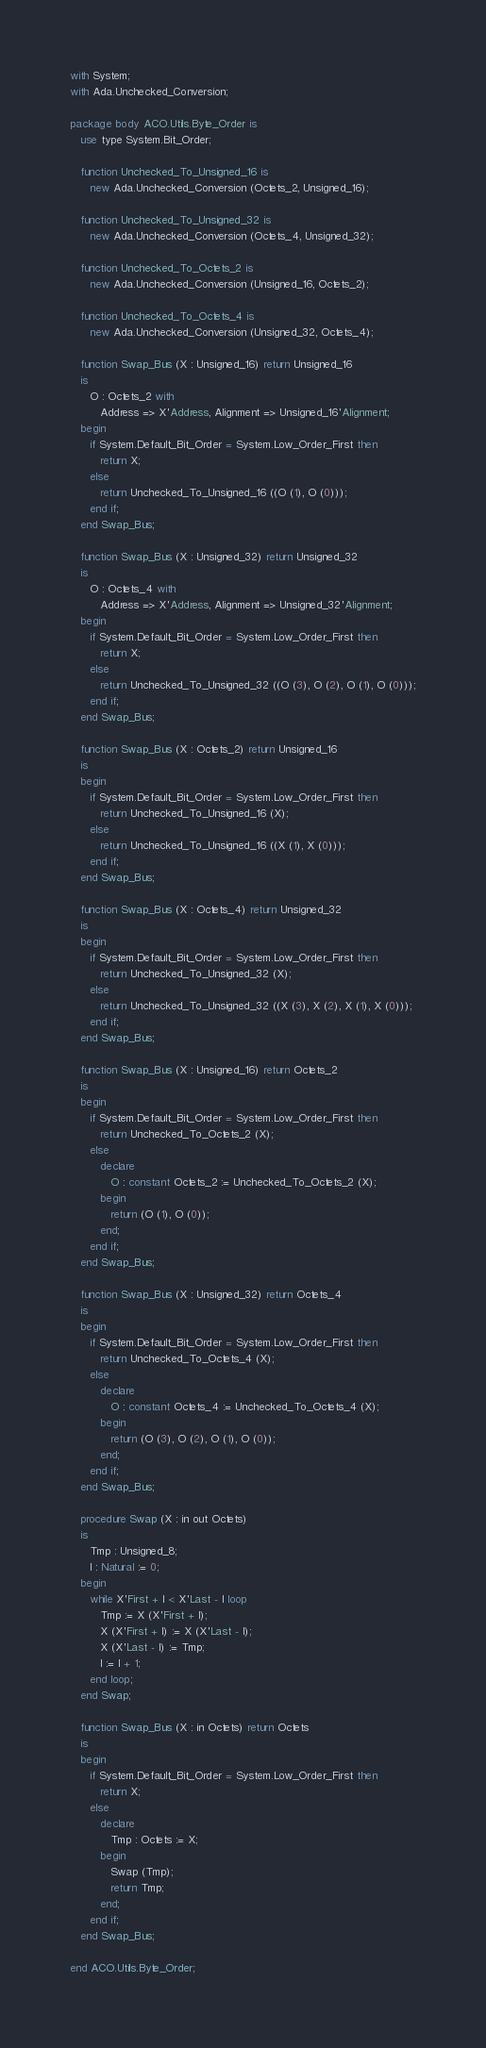<code> <loc_0><loc_0><loc_500><loc_500><_Ada_>with System;
with Ada.Unchecked_Conversion;

package body ACO.Utils.Byte_Order is
   use type System.Bit_Order;

   function Unchecked_To_Unsigned_16 is
      new Ada.Unchecked_Conversion (Octets_2, Unsigned_16);

   function Unchecked_To_Unsigned_32 is
      new Ada.Unchecked_Conversion (Octets_4, Unsigned_32);

   function Unchecked_To_Octets_2 is
      new Ada.Unchecked_Conversion (Unsigned_16, Octets_2);

   function Unchecked_To_Octets_4 is
      new Ada.Unchecked_Conversion (Unsigned_32, Octets_4);

   function Swap_Bus (X : Unsigned_16) return Unsigned_16
   is
      O : Octets_2 with
         Address => X'Address, Alignment => Unsigned_16'Alignment;
   begin
      if System.Default_Bit_Order = System.Low_Order_First then
         return X;
      else
         return Unchecked_To_Unsigned_16 ((O (1), O (0)));
      end if;
   end Swap_Bus;

   function Swap_Bus (X : Unsigned_32) return Unsigned_32
   is
      O : Octets_4 with
         Address => X'Address, Alignment => Unsigned_32'Alignment;
   begin
      if System.Default_Bit_Order = System.Low_Order_First then
         return X;
      else
         return Unchecked_To_Unsigned_32 ((O (3), O (2), O (1), O (0)));
      end if;
   end Swap_Bus;

   function Swap_Bus (X : Octets_2) return Unsigned_16
   is
   begin
      if System.Default_Bit_Order = System.Low_Order_First then
         return Unchecked_To_Unsigned_16 (X);
      else
         return Unchecked_To_Unsigned_16 ((X (1), X (0)));
      end if;
   end Swap_Bus;

   function Swap_Bus (X : Octets_4) return Unsigned_32
   is
   begin
      if System.Default_Bit_Order = System.Low_Order_First then
         return Unchecked_To_Unsigned_32 (X);
      else
         return Unchecked_To_Unsigned_32 ((X (3), X (2), X (1), X (0)));
      end if;
   end Swap_Bus;

   function Swap_Bus (X : Unsigned_16) return Octets_2
   is
   begin
      if System.Default_Bit_Order = System.Low_Order_First then
         return Unchecked_To_Octets_2 (X);
      else
         declare
            O : constant Octets_2 := Unchecked_To_Octets_2 (X);
         begin
            return (O (1), O (0));
         end;
      end if;
   end Swap_Bus;

   function Swap_Bus (X : Unsigned_32) return Octets_4
   is
   begin
      if System.Default_Bit_Order = System.Low_Order_First then
         return Unchecked_To_Octets_4 (X);
      else
         declare
            O : constant Octets_4 := Unchecked_To_Octets_4 (X);
         begin
            return (O (3), O (2), O (1), O (0));
         end;
      end if;
   end Swap_Bus;

   procedure Swap (X : in out Octets)
   is
      Tmp : Unsigned_8;
      I : Natural := 0;
   begin
      while X'First + I < X'Last - I loop
         Tmp := X (X'First + I);
         X (X'First + I) := X (X'Last - I);
         X (X'Last - I) := Tmp;
         I := I + 1;
      end loop;
   end Swap;

   function Swap_Bus (X : in Octets) return Octets
   is
   begin
      if System.Default_Bit_Order = System.Low_Order_First then
         return X;
      else
         declare
            Tmp : Octets := X;
         begin
            Swap (Tmp);
            return Tmp;
         end;
      end if;
   end Swap_Bus;

end ACO.Utils.Byte_Order;
</code> 